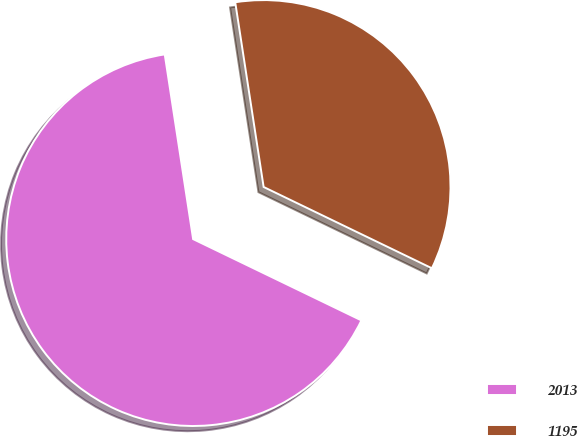Convert chart to OTSL. <chart><loc_0><loc_0><loc_500><loc_500><pie_chart><fcel>2013<fcel>1195<nl><fcel>65.41%<fcel>34.59%<nl></chart> 